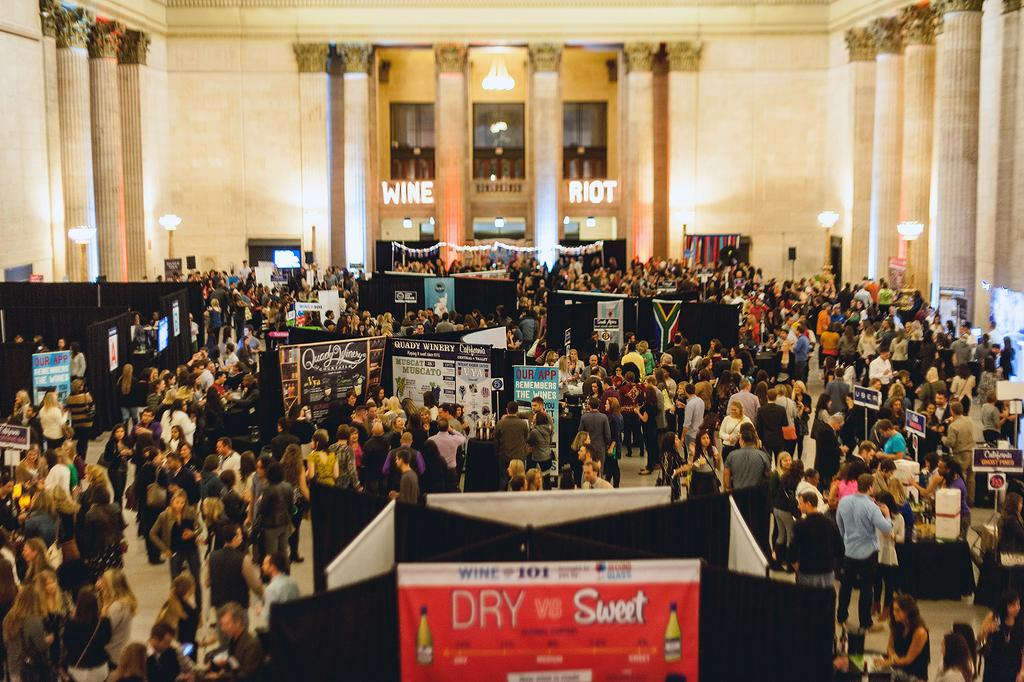How many people are present in the image? There are many people in the image. What can be seen on the boards in the image? There are boards with text in the image. What type of lighting is present in the image? There are lights in the image. What architectural features can be seen in the image? There are pillars in the image. What type of walls are visible in the background? There are glass walls visible in the background. What can be read on the wall in the background? There is text on the wall in the background. Can you tell me where the goat is located in the image? There is no goat present in the image. What type of shop can be seen in the background of the image? There is no shop visible in the image; it features people, boards with text, lights, pillars, and glass walls with text on the wall in the background. 